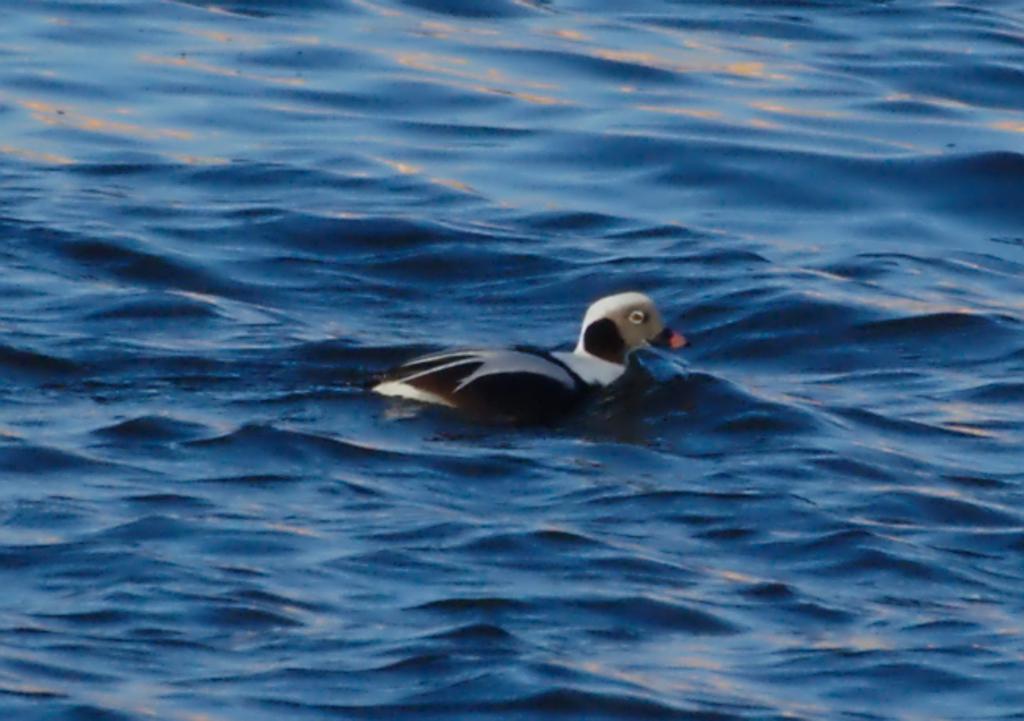Describe this image in one or two sentences. In this image I can see water and on it I can see a brown and white colour bird. 